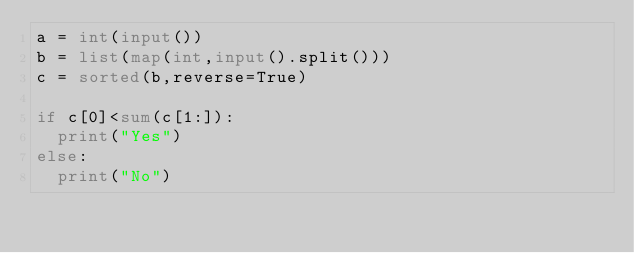<code> <loc_0><loc_0><loc_500><loc_500><_Python_>a = int(input())
b = list(map(int,input().split()))
c = sorted(b,reverse=True)

if c[0]<sum(c[1:]):
  print("Yes")
else:
  print("No")</code> 